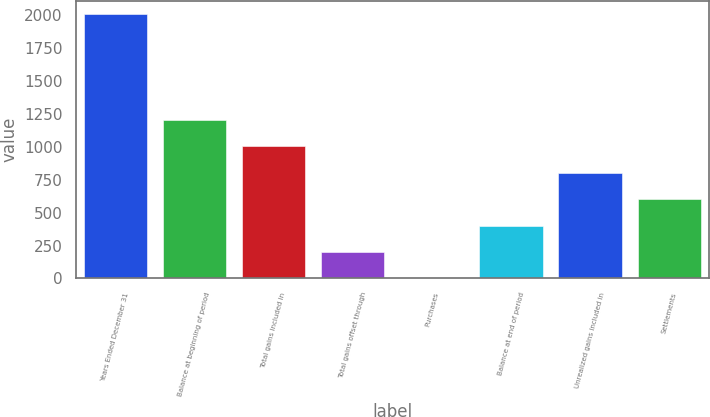Convert chart. <chart><loc_0><loc_0><loc_500><loc_500><bar_chart><fcel>Years Ended December 31<fcel>Balance at beginning of period<fcel>Total gains included in<fcel>Total gains offset through<fcel>Purchases<fcel>Balance at end of period<fcel>Unrealized gains included in<fcel>Settlements<nl><fcel>2010<fcel>1206.4<fcel>1005.5<fcel>201.9<fcel>1<fcel>402.8<fcel>804.6<fcel>603.7<nl></chart> 